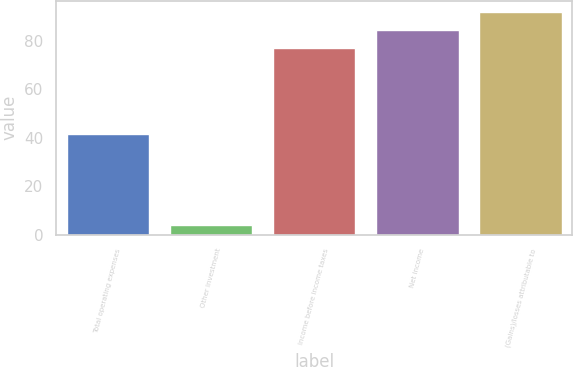Convert chart. <chart><loc_0><loc_0><loc_500><loc_500><bar_chart><fcel>Total operating expenses<fcel>Other investment<fcel>Income before income taxes<fcel>Net income<fcel>(Gains)/losses attributable to<nl><fcel>41.4<fcel>3.8<fcel>77.1<fcel>84.43<fcel>91.76<nl></chart> 